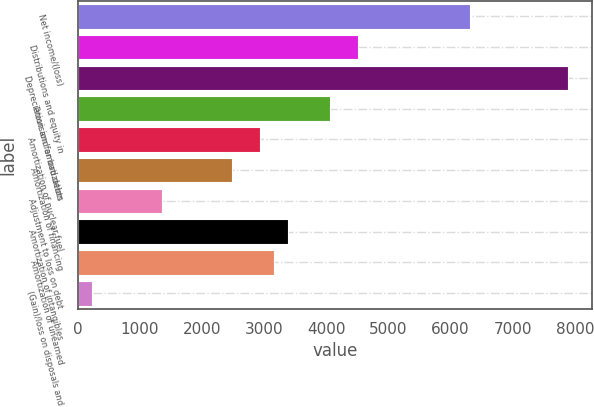Convert chart to OTSL. <chart><loc_0><loc_0><loc_500><loc_500><bar_chart><fcel>Net income/(loss)<fcel>Distributions and equity in<fcel>Depreciation and amortization<fcel>Provision for bad debts<fcel>Amortization of nuclear fuel<fcel>Amortization of financing<fcel>Adjustment to loss on debt<fcel>Amortization of intangibles<fcel>Amortization of unearned<fcel>(Gain)/loss on disposals and<nl><fcel>6307.6<fcel>4506<fcel>7884<fcel>4055.6<fcel>2929.6<fcel>2479.2<fcel>1353.2<fcel>3380<fcel>3154.8<fcel>227.2<nl></chart> 